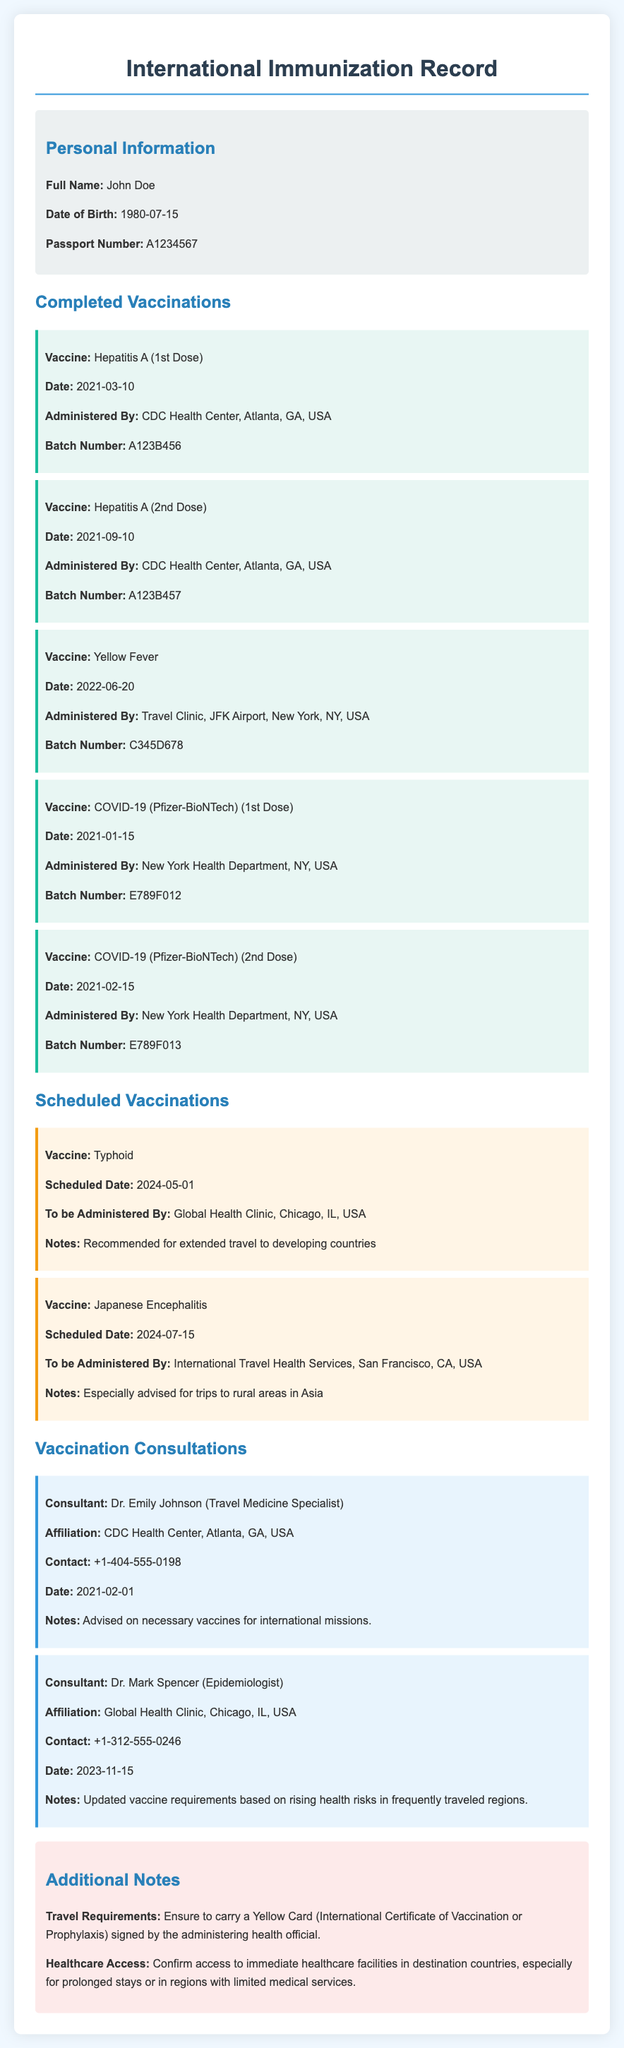What is the full name of the individual? The full name of the individual is provided in the personal information section, which states "John Doe."
Answer: John Doe When was the first dose of the Hepatitis A vaccine administered? The document lists the date of the first dose of Hepatitis A vaccine as "2021-03-10."
Answer: 2021-03-10 How many doses of COVID-19 vaccine did the individual receive? The vaccination record shows two doses of COVID-19 (Pfizer-BioNTech) were administered.
Answer: 2 What is the scheduled date for the Typhoid vaccine? The scheduled date for the Typhoid vaccine is explicitly mentioned as "2024-05-01."
Answer: 2024-05-01 Who is the consulting doctor for travel medicine? The document identifies Dr. Emily Johnson as the travel medicine specialist providing consultation.
Answer: Dr. Emily Johnson What is the contact number for the Global Health Clinic? The contact number provided for the Global Health Clinic is "+1-312-555-0246."
Answer: +1-312-555-0246 Which vaccine is scheduled for July 15, 2024? The scheduled vaccine on that date is mentioned as "Japanese Encephalitis."
Answer: Japanese Encephalitis What does the document advise to carry for travel requirements? It states that the individual should carry a "Yellow Card."
Answer: Yellow Card What healthcare access recommendation is mentioned for destination countries? It is advised to confirm "access to immediate healthcare facilities" in destination countries.
Answer: access to immediate healthcare facilities 